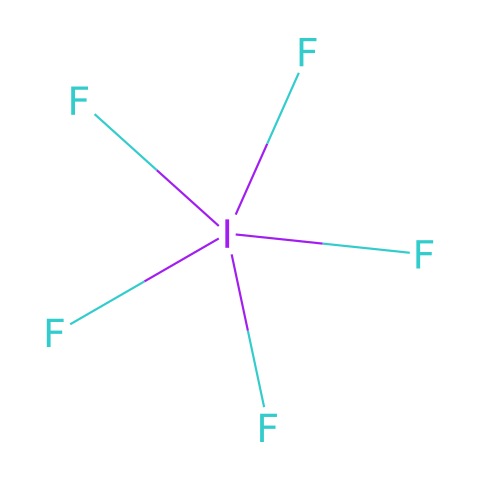What is the molecular formula of iodine pentafluoride? The SMILES representation indicates an iodine atom bonded to five fluorine atoms, leading to the formula IF5.
Answer: IF5 How many total bonds are present in iodine pentafluoride? The iodine atom is bonded to five fluorine atoms, resulting in a total of five single bonds.
Answer: 5 Which atom serves as the central atom in this compound? In the structure represented by the SMILES, the iodine atom is depicted as the central atom surrounded by multiple fluorine atoms.
Answer: iodine What type of compound is iodine pentafluoride classified as? Iodine pentafluoride is classified as a hypervalent compound since the iodine atom is surrounded by more than four bonds.
Answer: hypervalent What is the oxidation state of iodine in iodine pentafluoride? The oxidation state of iodine in IF5 can be calculated as +5, considering that each fluorine has an oxidation state of -1.
Answer: +5 Why is iodine capable of forming five bonds in iodine pentafluoride? Iodine can expand its valence shell beyond the octet rule due to its higher principal energy level, allowing it to accommodate extra bonds.
Answer: higher principal energy level What property does iodine pentafluoride have due to its molecular structure? The molecular structure results in a highly polarized and strong oxidizing agent due to the presence of several electronegative fluorine atoms.
Answer: strong oxidizing agent 